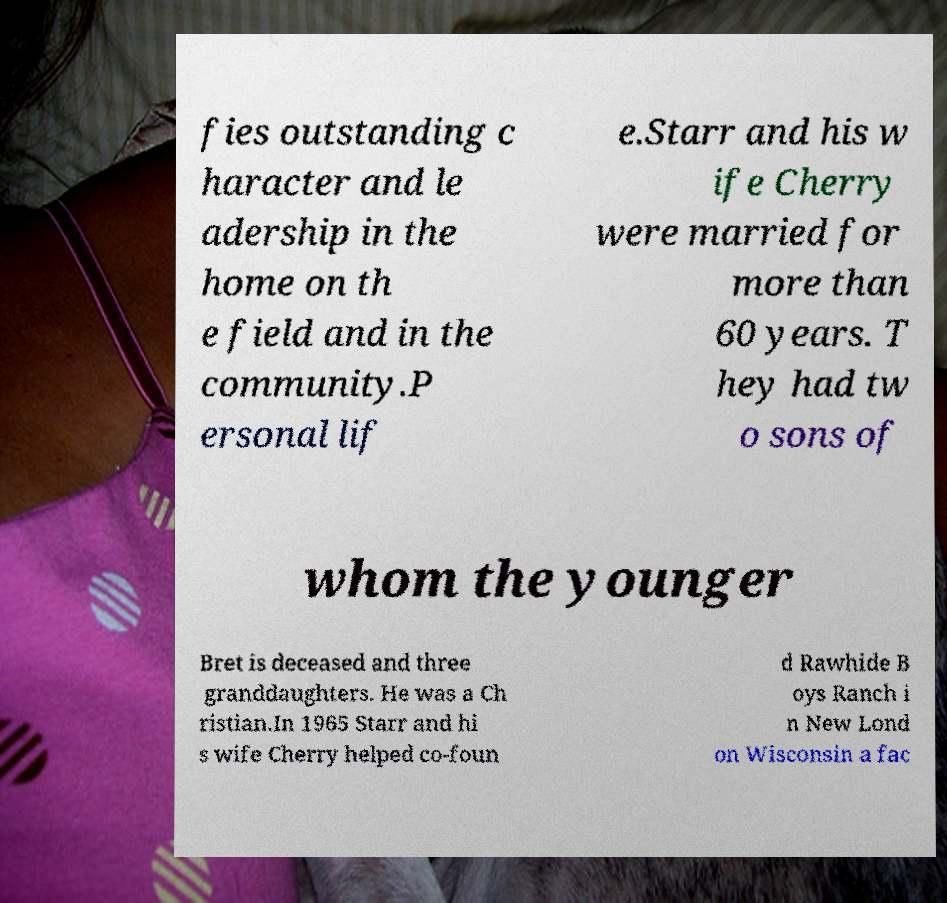I need the written content from this picture converted into text. Can you do that? fies outstanding c haracter and le adership in the home on th e field and in the community.P ersonal lif e.Starr and his w ife Cherry were married for more than 60 years. T hey had tw o sons of whom the younger Bret is deceased and three granddaughters. He was a Ch ristian.In 1965 Starr and hi s wife Cherry helped co-foun d Rawhide B oys Ranch i n New Lond on Wisconsin a fac 